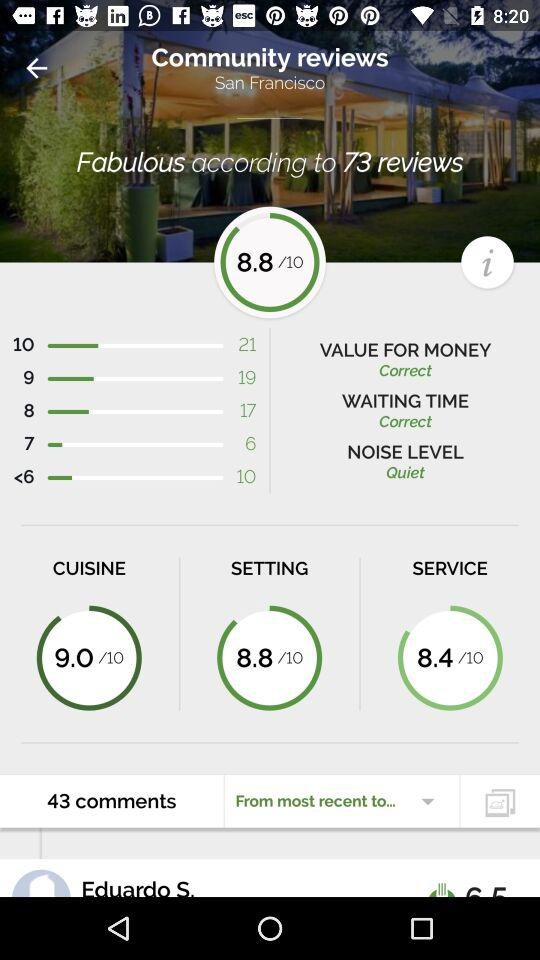What is the rating given by people to cuisine? The rating given by people to cuisine is 9. 